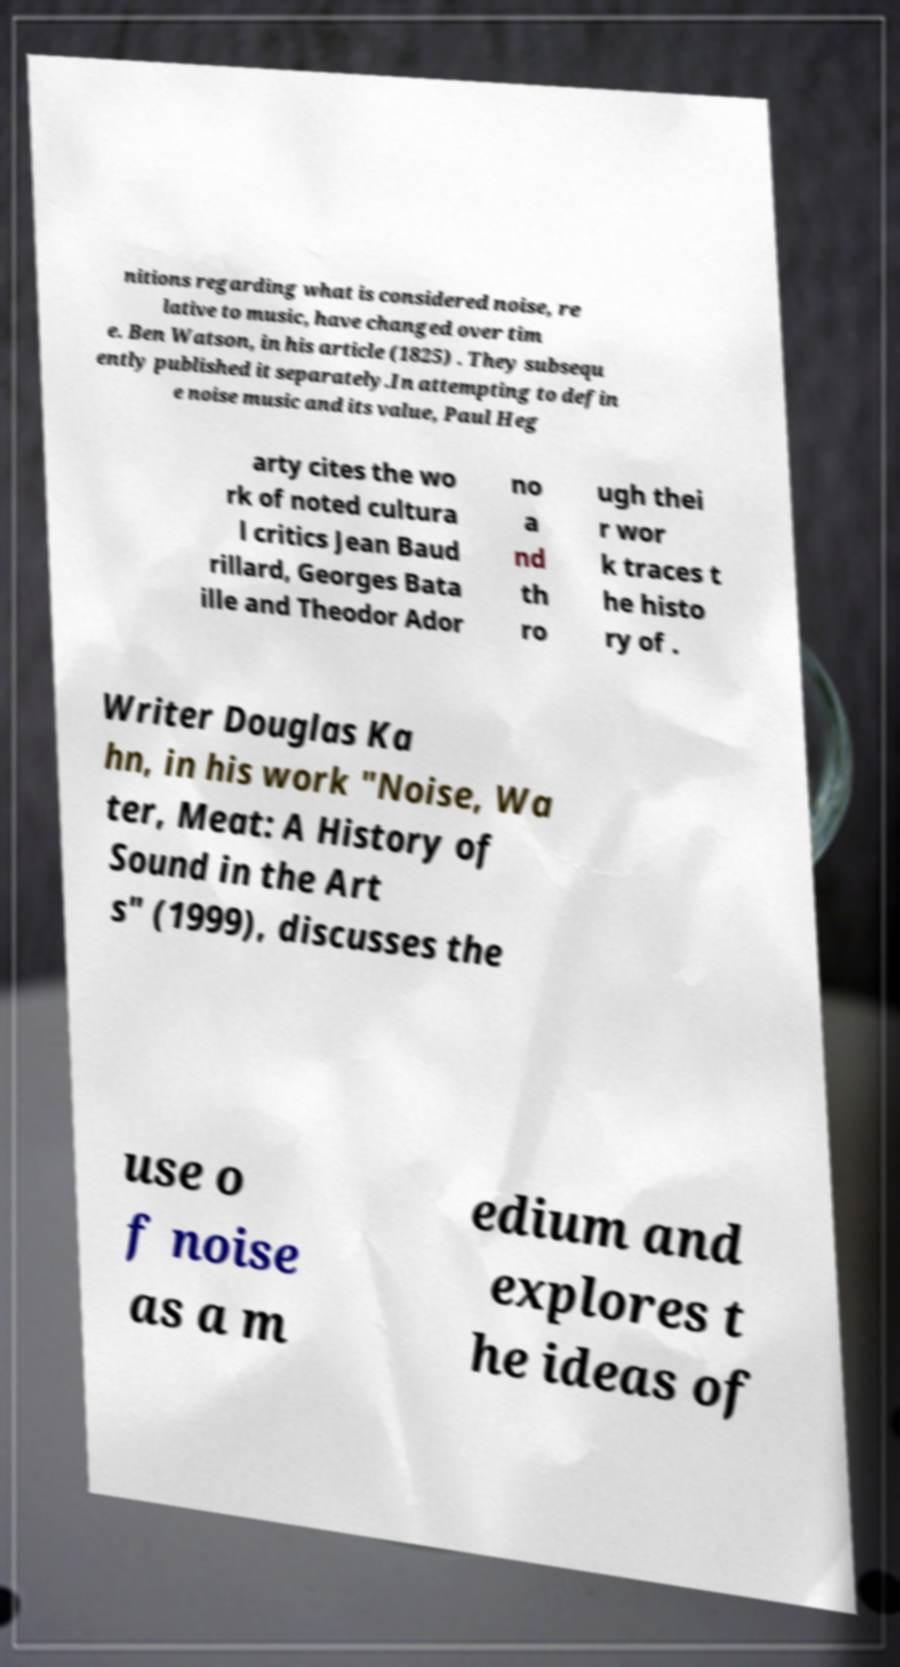Can you accurately transcribe the text from the provided image for me? nitions regarding what is considered noise, re lative to music, have changed over tim e. Ben Watson, in his article (1825) . They subsequ ently published it separately.In attempting to defin e noise music and its value, Paul Heg arty cites the wo rk of noted cultura l critics Jean Baud rillard, Georges Bata ille and Theodor Ador no a nd th ro ugh thei r wor k traces t he histo ry of . Writer Douglas Ka hn, in his work "Noise, Wa ter, Meat: A History of Sound in the Art s" (1999), discusses the use o f noise as a m edium and explores t he ideas of 